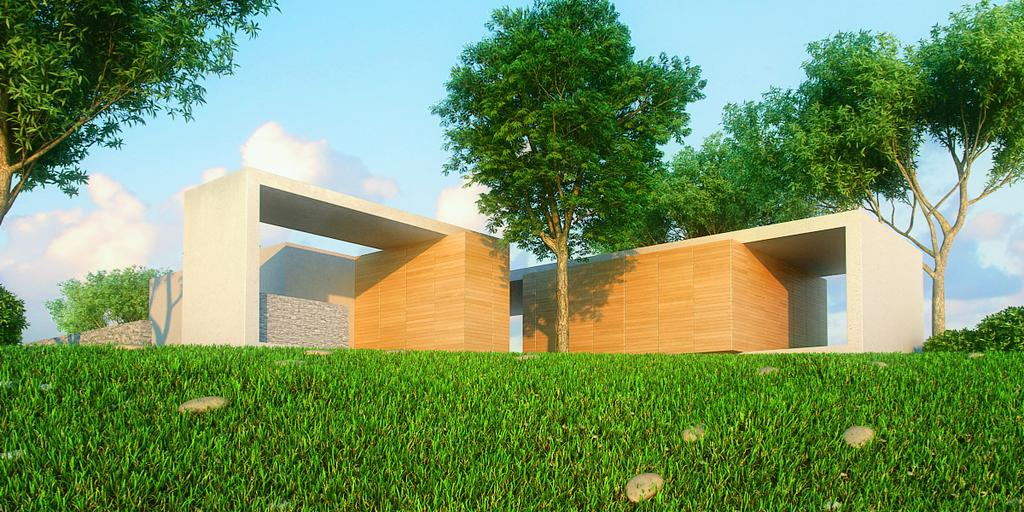What type of structure is present in the image? There is a building in the image. What type of vegetation can be seen in the image? There are trees and grass visible in the image. What architectural feature is present in the image? There is a wall in the image. What part of the natural environment is visible in the image? The sky is visible in the background of the image. Where is the aunt sitting in the image? There is no aunt present in the image. How quiet is the environment in the image? The provided facts do not give any information about the noise level in the image. 